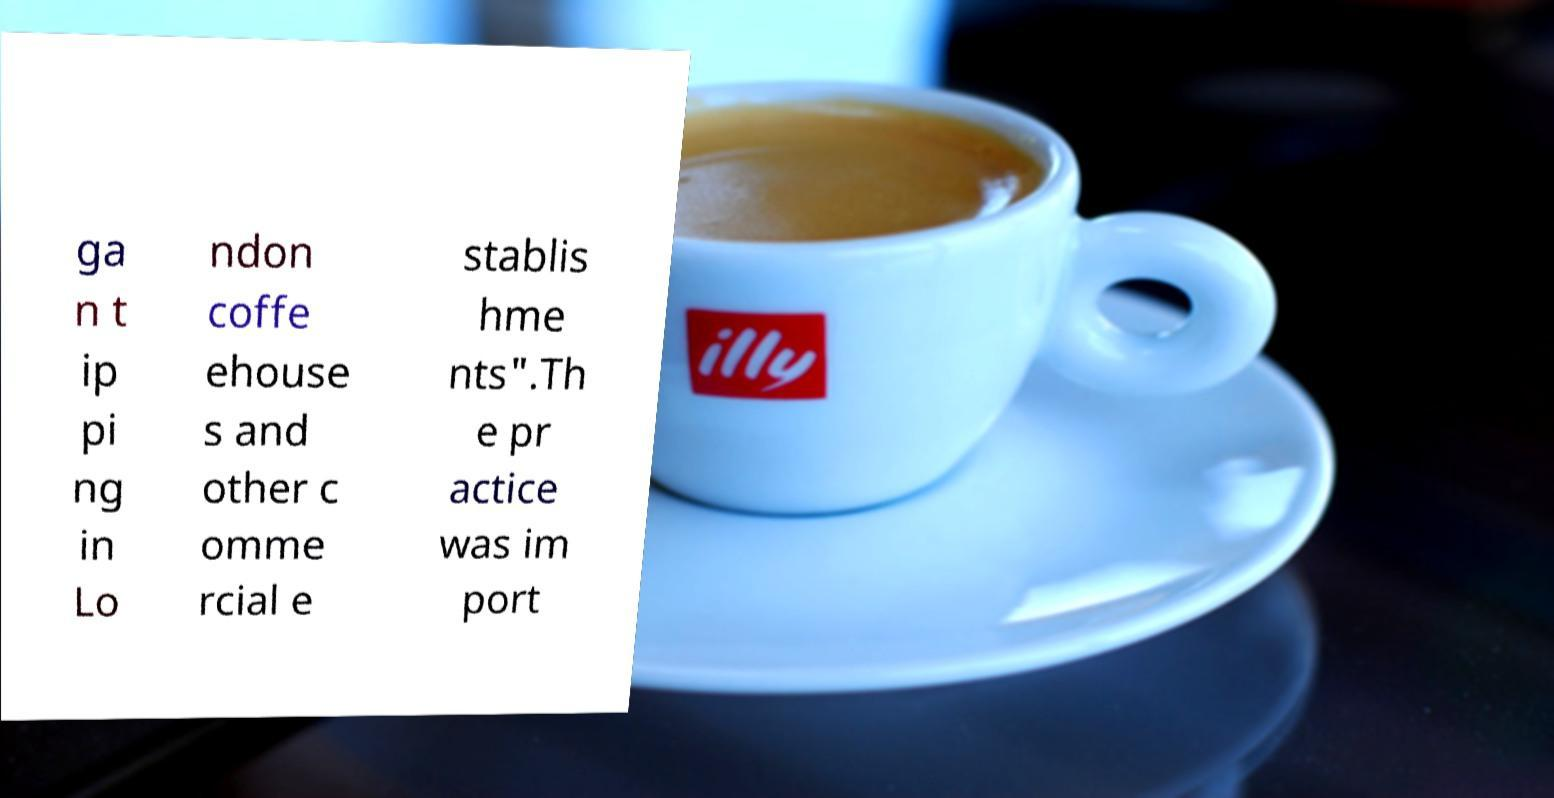Can you accurately transcribe the text from the provided image for me? ga n t ip pi ng in Lo ndon coffe ehouse s and other c omme rcial e stablis hme nts".Th e pr actice was im port 